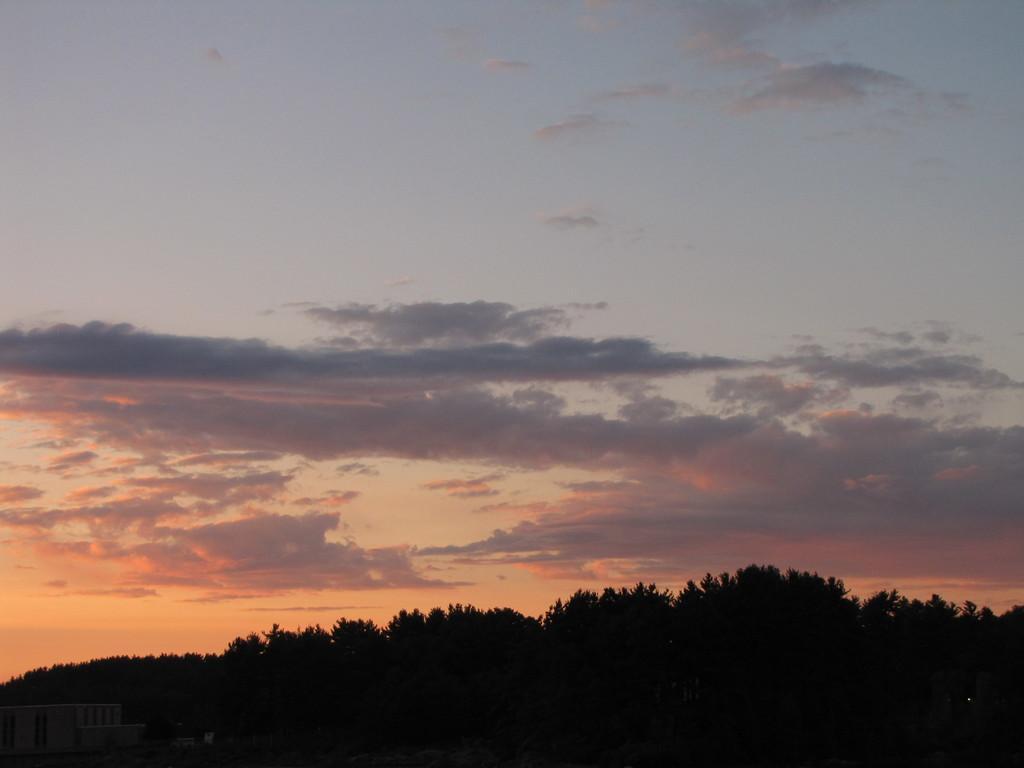Can you describe this image briefly? In this image I can see some houses, trees and cloudy sky. 